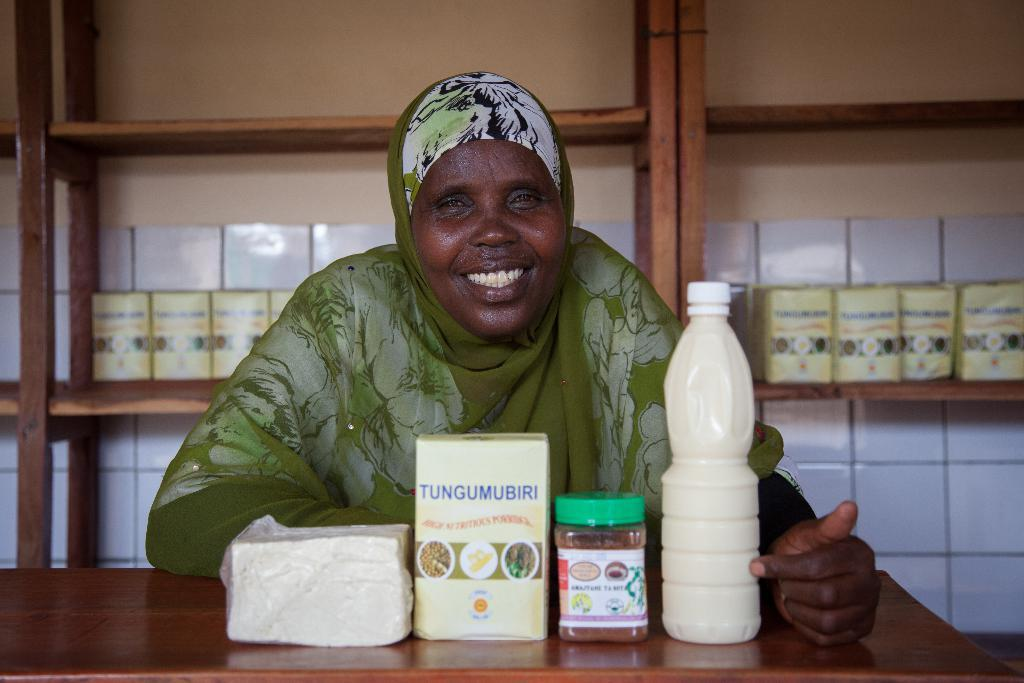Who is present in the image? There is a woman in the image. What is the woman's expression? The woman is smiling. What furniture or object can be seen in the image? There is a table in the image. What items are on the table? There are tissues, boxes, and a bottle on the table. What can be seen in the background of the image? There is a rack visible in the background of the image. What type of plant is hanging from the curtain in the image? There is no plant hanging from a curtain in the image, nor is there a curtain present. 